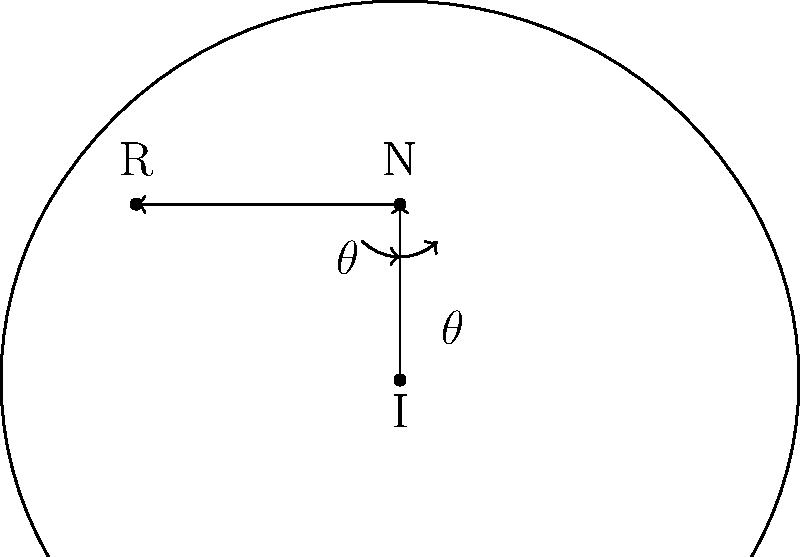While photographing a classic car with a curved surface at a car showcase, you notice that the angle of incidence equals the angle of reflection. If the incident ray makes an angle of 45° with the normal to the surface at the point of incidence, what is the angle between the incident ray and the reflected ray? Let's approach this step-by-step:

1) First, recall the law of reflection: the angle of incidence equals the angle of reflection.

2) In the diagram:
   - I represents the incident ray
   - N represents the normal to the surface
   - R represents the reflected ray
   - $\theta$ represents both the angle of incidence and the angle of reflection

3) We're given that the incident ray makes a 45° angle with the normal. So:

   $\theta = 45°$

4) Since the angle of reflection is equal to the angle of incidence:

   Angle of reflection = $\theta = 45°$

5) To find the angle between the incident ray and the reflected ray, we need to add these two angles:

   Total angle = $\theta + \theta = 45° + 45° = 90°$

Therefore, the angle between the incident ray and the reflected ray is 90°.
Answer: 90° 